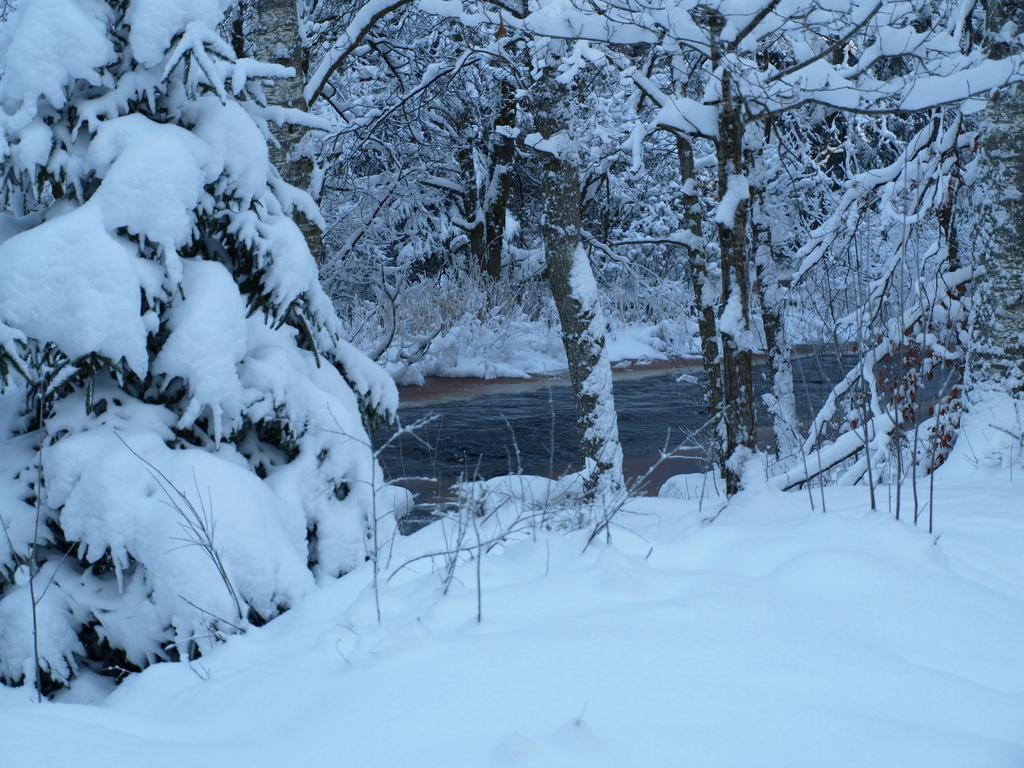Describe this image in one or two sentences. In this picture I can see snow on the trees and on the ground and I can see water. 